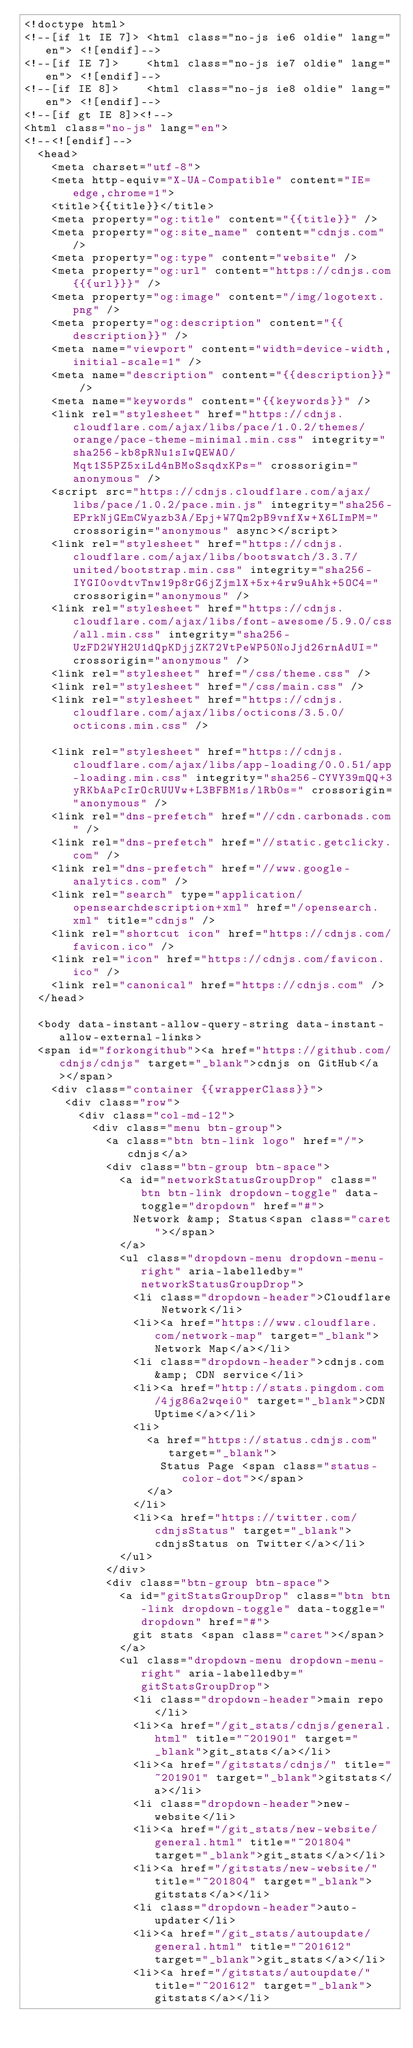<code> <loc_0><loc_0><loc_500><loc_500><_HTML_><!doctype html>
<!--[if lt IE 7]> <html class="no-js ie6 oldie" lang="en"> <![endif]-->
<!--[if IE 7]>    <html class="no-js ie7 oldie" lang="en"> <![endif]-->
<!--[if IE 8]>    <html class="no-js ie8 oldie" lang="en"> <![endif]-->
<!--[if gt IE 8]><!-->
<html class="no-js" lang="en">
<!--<![endif]-->
  <head>
    <meta charset="utf-8">
    <meta http-equiv="X-UA-Compatible" content="IE=edge,chrome=1">
    <title>{{title}}</title>
    <meta property="og:title" content="{{title}}" />
    <meta property="og:site_name" content="cdnjs.com" />
    <meta property="og:type" content="website" />
    <meta property="og:url" content="https://cdnjs.com{{{url}}}" />
    <meta property="og:image" content="/img/logotext.png" />
    <meta property="og:description" content="{{description}}" />
    <meta name="viewport" content="width=device-width,initial-scale=1" />
    <meta name="description" content="{{description}}" />
    <meta name="keywords" content="{{keywords}}" />
    <link rel="stylesheet" href="https://cdnjs.cloudflare.com/ajax/libs/pace/1.0.2/themes/orange/pace-theme-minimal.min.css" integrity="sha256-kb8pRNu1sIwQEWAO/Mqt1S5PZ5xiLd4nBMoSsqdxKPs=" crossorigin="anonymous" />
    <script src="https://cdnjs.cloudflare.com/ajax/libs/pace/1.0.2/pace.min.js" integrity="sha256-EPrkNjGEmCWyazb3A/Epj+W7Qm2pB9vnfXw+X6LImPM=" crossorigin="anonymous" async></script>
    <link rel="stylesheet" href="https://cdnjs.cloudflare.com/ajax/libs/bootswatch/3.3.7/united/bootstrap.min.css" integrity="sha256-IYGI0ovdtvTnw19p8rG6jZjmlX+5x+4rw9uAhk+5OC4=" crossorigin="anonymous" />
    <link rel="stylesheet" href="https://cdnjs.cloudflare.com/ajax/libs/font-awesome/5.9.0/css/all.min.css" integrity="sha256-UzFD2WYH2U1dQpKDjjZK72VtPeWP50NoJjd26rnAdUI=" crossorigin="anonymous" />
    <link rel="stylesheet" href="/css/theme.css" />
    <link rel="stylesheet" href="/css/main.css" />
    <link rel="stylesheet" href="https://cdnjs.cloudflare.com/ajax/libs/octicons/3.5.0/octicons.min.css" />

    <link rel="stylesheet" href="https://cdnjs.cloudflare.com/ajax/libs/app-loading/0.0.51/app-loading.min.css" integrity="sha256-CYVY39mQQ+3yRKbAaPcIrOcRUUVw+L3BFBM1s/lRb0s=" crossorigin="anonymous" />
    <link rel="dns-prefetch" href="//cdn.carbonads.com" />
    <link rel="dns-prefetch" href="//static.getclicky.com" />
    <link rel="dns-prefetch" href="//www.google-analytics.com" />
    <link rel="search" type="application/opensearchdescription+xml" href="/opensearch.xml" title="cdnjs" />
    <link rel="shortcut icon" href="https://cdnjs.com/favicon.ico" />
    <link rel="icon" href="https://cdnjs.com/favicon.ico" />
    <link rel="canonical" href="https://cdnjs.com" />
  </head>

  <body data-instant-allow-query-string data-instant-allow-external-links>
  <span id="forkongithub"><a href="https://github.com/cdnjs/cdnjs" target="_blank">cdnjs on GitHub</a></span>
    <div class="container {{wrapperClass}}">
      <div class="row">
        <div class="col-md-12">
          <div class="menu btn-group">
            <a class="btn btn-link logo" href="/">cdnjs</a>
            <div class="btn-group btn-space">
              <a id="networkStatusGroupDrop" class="btn btn-link dropdown-toggle" data-toggle="dropdown" href="#">
                Network &amp; Status<span class="caret"></span>
              </a>
              <ul class="dropdown-menu dropdown-menu-right" aria-labelledby="networkStatusGroupDrop">
                <li class="dropdown-header">Cloudflare Network</li>
                <li><a href="https://www.cloudflare.com/network-map" target="_blank">Network Map</a></li>
                <li class="dropdown-header">cdnjs.com &amp; CDN service</li>
                <li><a href="http://stats.pingdom.com/4jg86a2wqei0" target="_blank">CDN Uptime</a></li>
                <li>
                  <a href="https://status.cdnjs.com" target="_blank">
                    Status Page <span class="status-color-dot"></span>
                  </a>
                </li>
                <li><a href="https://twitter.com/cdnjsStatus" target="_blank">cdnjsStatus on Twitter</a></li>
              </ul>
            </div>
            <div class="btn-group btn-space">
              <a id="gitStatsGroupDrop" class="btn btn-link dropdown-toggle" data-toggle="dropdown" href="#">
                git stats <span class="caret"></span>
              </a>
              <ul class="dropdown-menu dropdown-menu-right" aria-labelledby="gitStatsGroupDrop">
                <li class="dropdown-header">main repo</li>
                <li><a href="/git_stats/cdnjs/general.html" title="~201901" target="_blank">git_stats</a></li>
                <li><a href="/gitstats/cdnjs/" title="~201901" target="_blank">gitstats</a></li>
                <li class="dropdown-header">new-website</li>
                <li><a href="/git_stats/new-website/general.html" title="~201804" target="_blank">git_stats</a></li>
                <li><a href="/gitstats/new-website/" title="~201804" target="_blank">gitstats</a></li>
                <li class="dropdown-header">auto-updater</li>
                <li><a href="/git_stats/autoupdate/general.html" title="~201612" target="_blank">git_stats</a></li>
                <li><a href="/gitstats/autoupdate/" title="~201612" target="_blank">gitstats</a></li></code> 